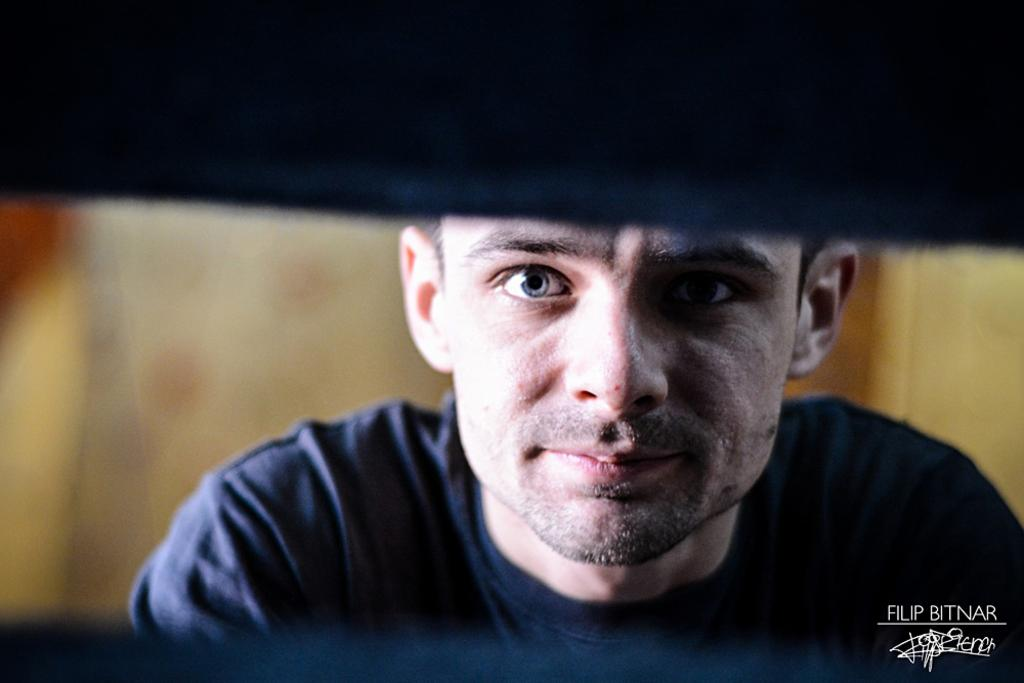Who is present in the image? There is a man in the image. What is the man wearing? The man is wearing a t-shirt. Can you describe any additional features of the image? There is a watermark on the right side of the image, and the background is blurred. Can you tell me how many animals are in the man's home in the image? There is no information about the man's home or any animals in the image. 